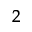Convert formula to latex. <formula><loc_0><loc_0><loc_500><loc_500>_ { 2 }</formula> 